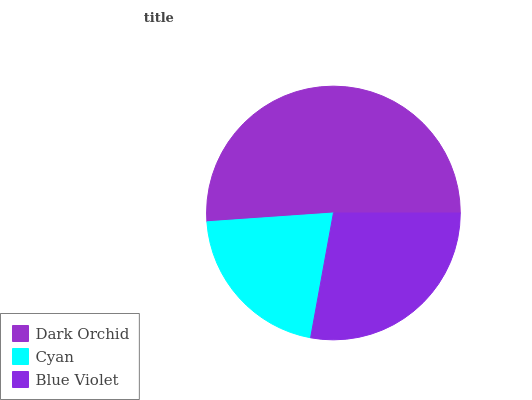Is Cyan the minimum?
Answer yes or no. Yes. Is Dark Orchid the maximum?
Answer yes or no. Yes. Is Blue Violet the minimum?
Answer yes or no. No. Is Blue Violet the maximum?
Answer yes or no. No. Is Blue Violet greater than Cyan?
Answer yes or no. Yes. Is Cyan less than Blue Violet?
Answer yes or no. Yes. Is Cyan greater than Blue Violet?
Answer yes or no. No. Is Blue Violet less than Cyan?
Answer yes or no. No. Is Blue Violet the high median?
Answer yes or no. Yes. Is Blue Violet the low median?
Answer yes or no. Yes. Is Dark Orchid the high median?
Answer yes or no. No. Is Cyan the low median?
Answer yes or no. No. 